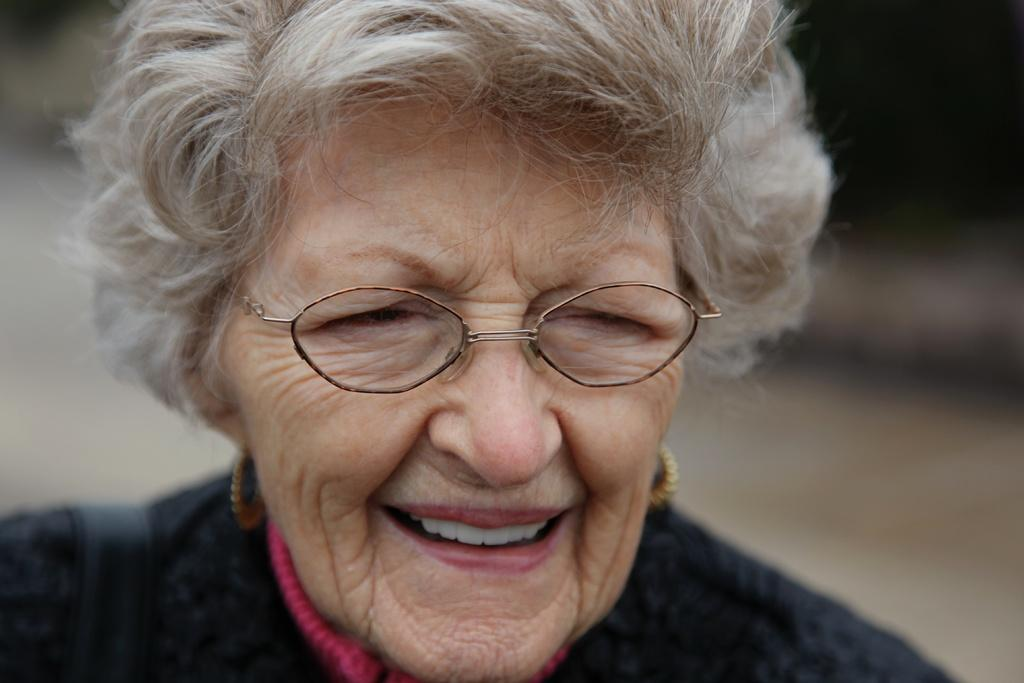Who is the main subject in the image? There is a woman in the image. What is the woman wearing? The woman is wearing spectacles. What is the woman's facial expression? The woman is smiling. Can you describe the background of the image? The background of the image is blurry. How many ants can be seen on the shelf in the image? There are no ants or shelves present in the image. What time does the clock show in the image? There is no clock present in the image. 